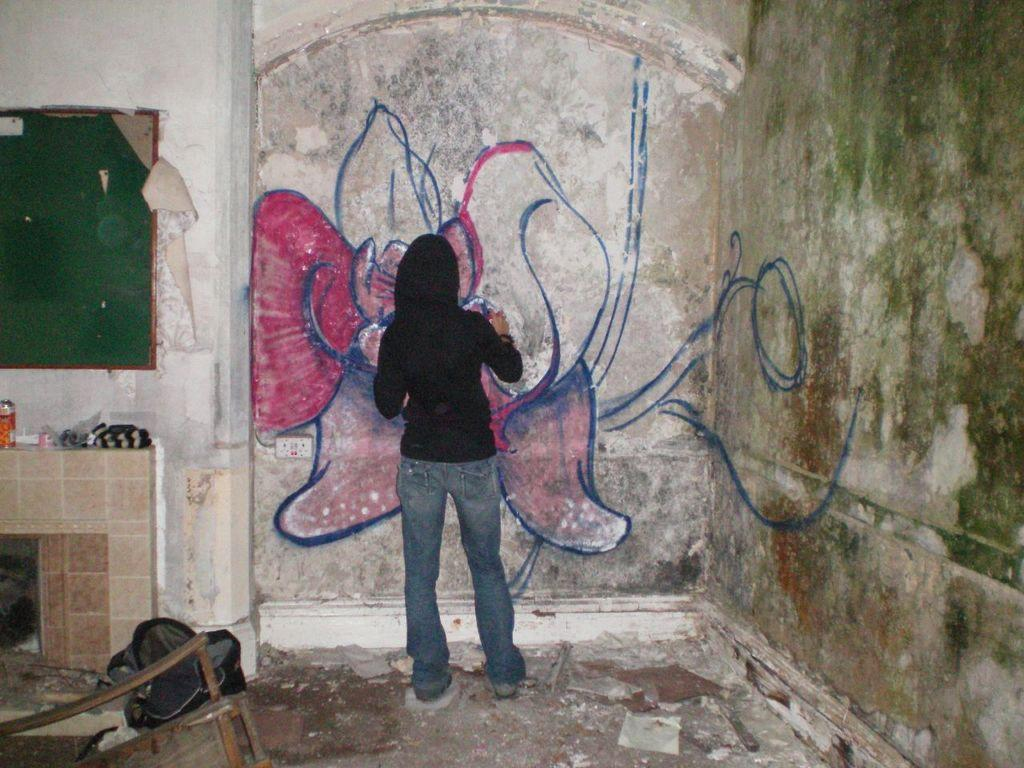What is the person in the image doing? The person is painting on a wall. Where is the painting located in the image? The painting is in the middle of the image. What else can be seen on the left side of the image? There is a board on the left side of the image. What type of potato is being used as a brush in the image? There is no potato being used as a brush in the image; the person is using a traditional paintbrush. Can you describe the teeth of the person painting in the image? There is no mention of the person's teeth in the image, as the focus is on their painting activity. 